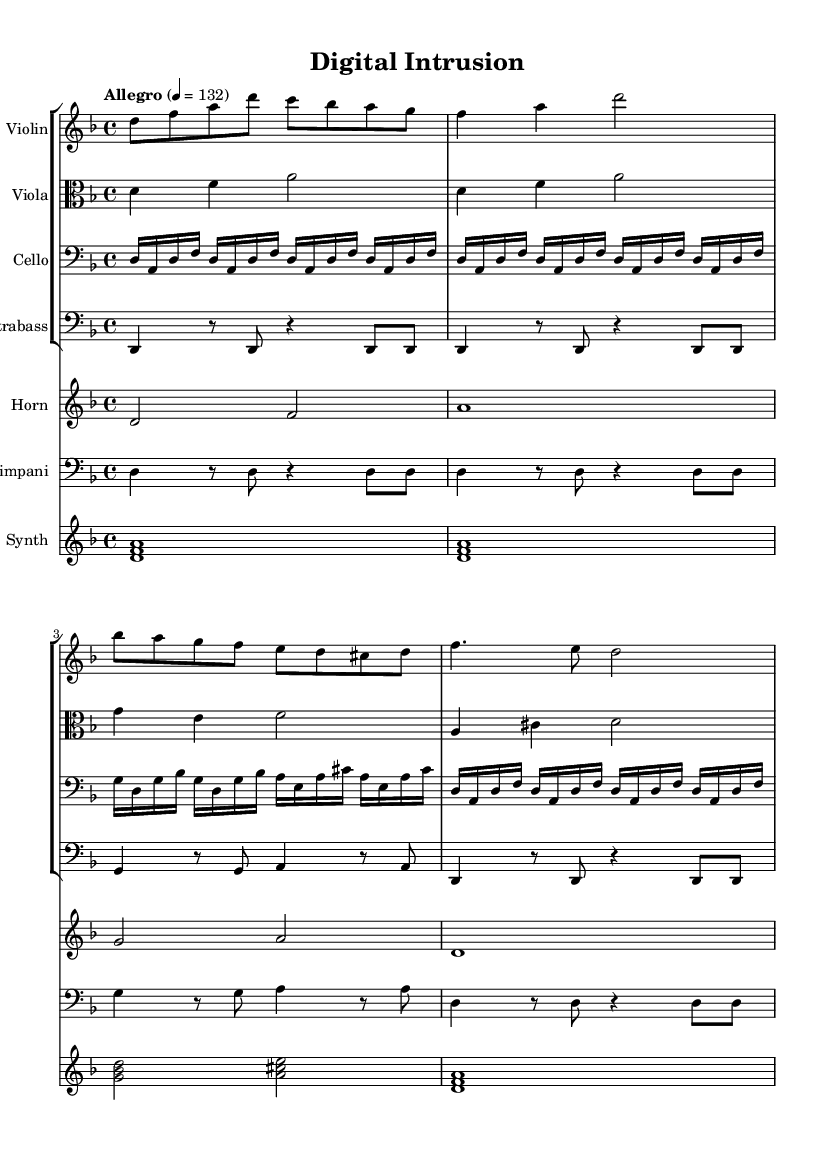What is the key signature of this music? The key signature is indicated at the beginning of the score, which shows two flats (B flat and E flat), identifying it as D minor.
Answer: D minor What is the time signature of the piece? The time signature, located right after the key signature, is 4/4, indicating there are four beats in a measure.
Answer: 4/4 What is the tempo marking of the score? The tempo marking is found above the staff, stating "Allegro" with a metronome marking of 132 beats per minute, indicating a fast pace.
Answer: Allegro, 132 How many measures does the violin part contain? By counting the number of measures in the violin part, we see it has 8 measures in total.
Answer: 8 What instruments are included in this score? The score includes Violin, Viola, Cello, Contrabass, Horn, Timpani, and Synth, which can be identified by looking at the different staves at the beginning.
Answer: Violin, Viola, Cello, Contrabass, Horn, Timpani, Synth Which instrument plays the highest pitch in this score? Examining the pitches in each staff, the Violin generally plays the highest pitches, reaching notes like A and C.
Answer: Violin What mood does this tense orchestral score aim to convey? The intricate rhythms, dynamic contrasts, and dissonance indicate a suspenseful and high-stakes atmosphere typical of hacker thriller films.
Answer: Suspenseful 